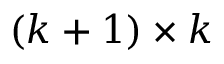<formula> <loc_0><loc_0><loc_500><loc_500>( k + 1 ) \times k</formula> 